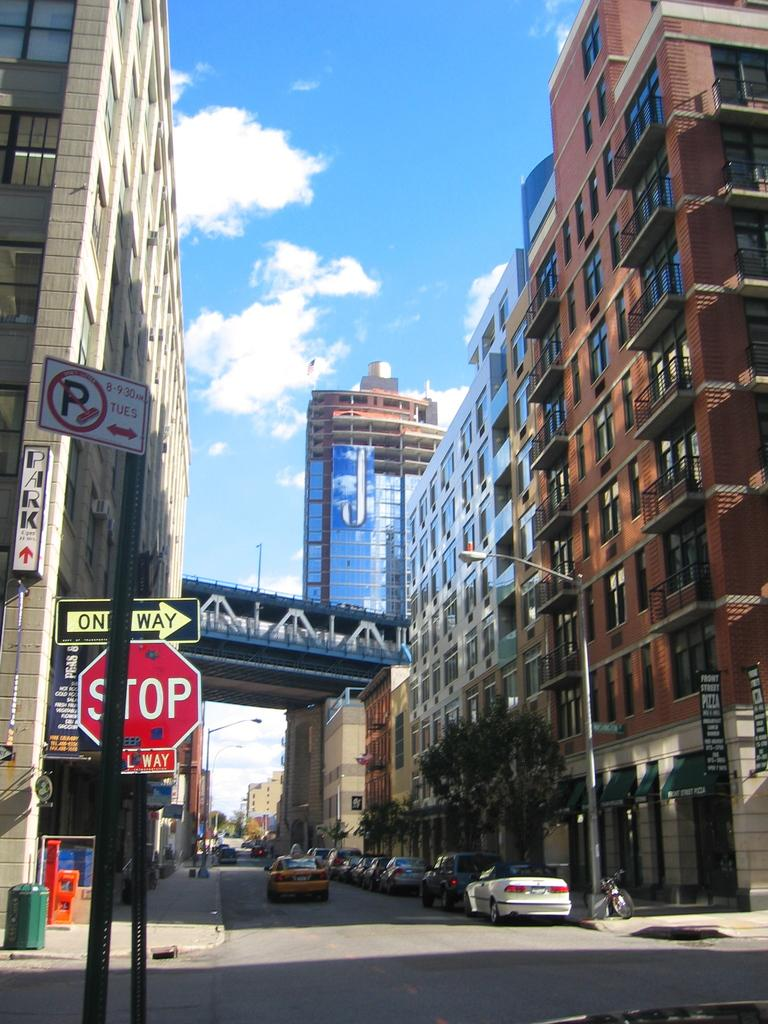What type of structures can be seen in the image? There are buildings in the image. What else is visible besides the buildings? There are vehicles, poles, lights, name boards, sign boards, and objects on the ground in the image. Can you describe the lighting in the image? There are lights visible in the image. What is visible in the background of the image? The sky is visible in the image. What type of argument is taking place between the buildings in the image? There is no argument present in the image; it features buildings, vehicles, poles, lights, name boards, sign boards, and objects on the ground. How many quarters are visible in the image? There is no mention of quarters in the image; it does not contain any coins or references to a quarter. 